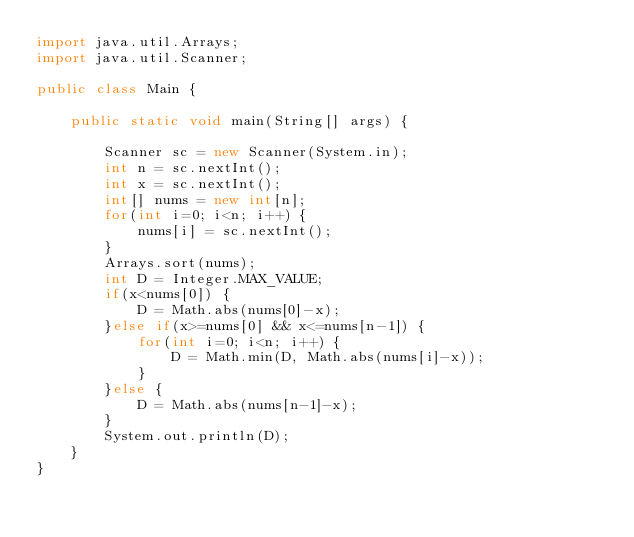<code> <loc_0><loc_0><loc_500><loc_500><_Java_>import java.util.Arrays;
import java.util.Scanner;

public class Main {

	public static void main(String[] args) {
		
		Scanner sc = new Scanner(System.in);
		int n = sc.nextInt();
		int x = sc.nextInt();
		int[] nums = new int[n];
		for(int i=0; i<n; i++) {
			nums[i] = sc.nextInt();
		}
		Arrays.sort(nums);
		int D = Integer.MAX_VALUE;
		if(x<nums[0]) {
			D = Math.abs(nums[0]-x);
		}else if(x>=nums[0] && x<=nums[n-1]) {
			for(int i=0; i<n; i++) {
				D = Math.min(D, Math.abs(nums[i]-x));
			}
		}else {
			D = Math.abs(nums[n-1]-x);
		}
		System.out.println(D);
	}
}
</code> 